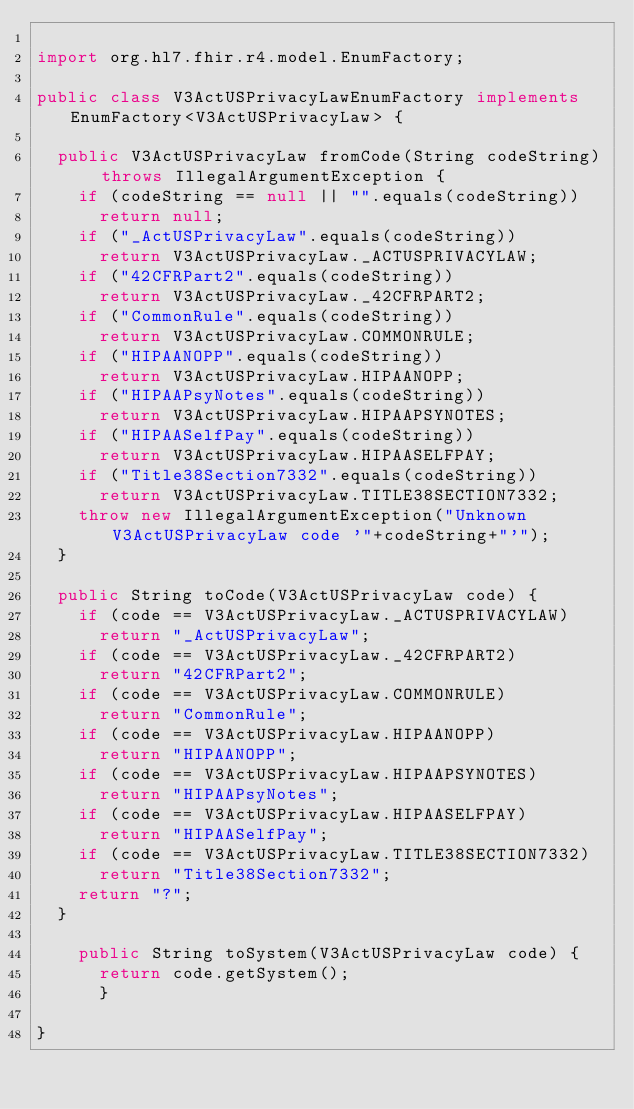Convert code to text. <code><loc_0><loc_0><loc_500><loc_500><_Java_>
import org.hl7.fhir.r4.model.EnumFactory;

public class V3ActUSPrivacyLawEnumFactory implements EnumFactory<V3ActUSPrivacyLaw> {

  public V3ActUSPrivacyLaw fromCode(String codeString) throws IllegalArgumentException {
    if (codeString == null || "".equals(codeString))
      return null;
    if ("_ActUSPrivacyLaw".equals(codeString))
      return V3ActUSPrivacyLaw._ACTUSPRIVACYLAW;
    if ("42CFRPart2".equals(codeString))
      return V3ActUSPrivacyLaw._42CFRPART2;
    if ("CommonRule".equals(codeString))
      return V3ActUSPrivacyLaw.COMMONRULE;
    if ("HIPAANOPP".equals(codeString))
      return V3ActUSPrivacyLaw.HIPAANOPP;
    if ("HIPAAPsyNotes".equals(codeString))
      return V3ActUSPrivacyLaw.HIPAAPSYNOTES;
    if ("HIPAASelfPay".equals(codeString))
      return V3ActUSPrivacyLaw.HIPAASELFPAY;
    if ("Title38Section7332".equals(codeString))
      return V3ActUSPrivacyLaw.TITLE38SECTION7332;
    throw new IllegalArgumentException("Unknown V3ActUSPrivacyLaw code '"+codeString+"'");
  }

  public String toCode(V3ActUSPrivacyLaw code) {
    if (code == V3ActUSPrivacyLaw._ACTUSPRIVACYLAW)
      return "_ActUSPrivacyLaw";
    if (code == V3ActUSPrivacyLaw._42CFRPART2)
      return "42CFRPart2";
    if (code == V3ActUSPrivacyLaw.COMMONRULE)
      return "CommonRule";
    if (code == V3ActUSPrivacyLaw.HIPAANOPP)
      return "HIPAANOPP";
    if (code == V3ActUSPrivacyLaw.HIPAAPSYNOTES)
      return "HIPAAPsyNotes";
    if (code == V3ActUSPrivacyLaw.HIPAASELFPAY)
      return "HIPAASelfPay";
    if (code == V3ActUSPrivacyLaw.TITLE38SECTION7332)
      return "Title38Section7332";
    return "?";
  }

    public String toSystem(V3ActUSPrivacyLaw code) {
      return code.getSystem();
      }

}

</code> 